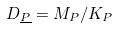<formula> <loc_0><loc_0><loc_500><loc_500>D _ { \underline { P } } = M _ { P } / K _ { P }</formula> 